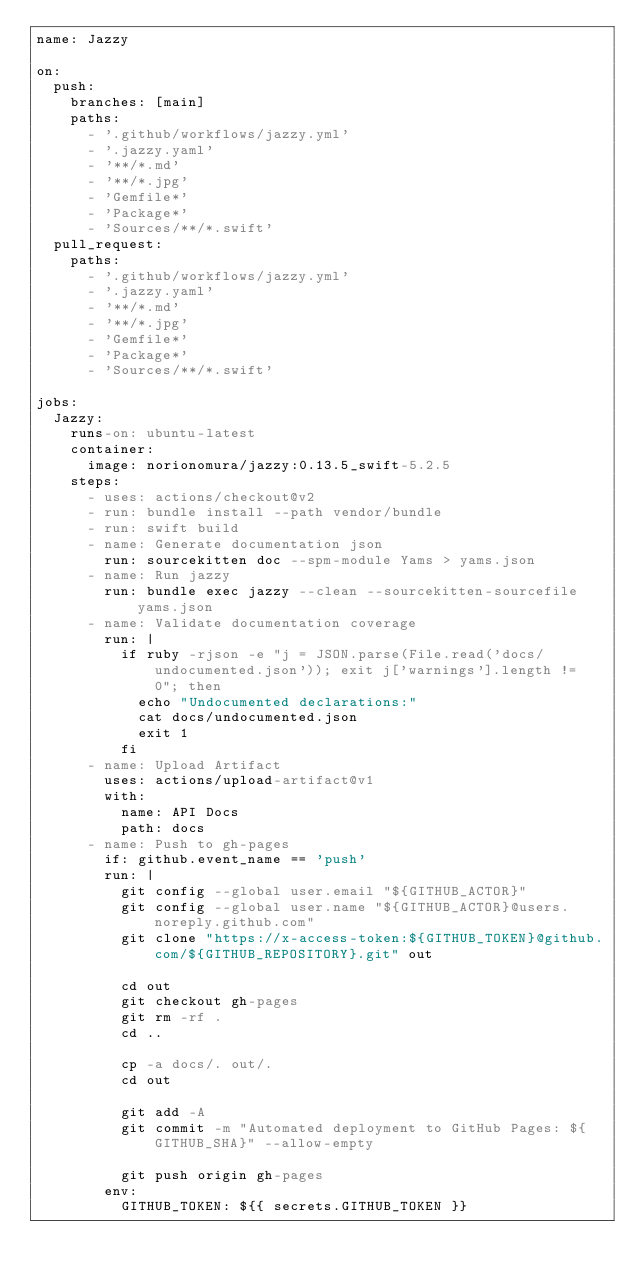<code> <loc_0><loc_0><loc_500><loc_500><_YAML_>name: Jazzy

on:
  push:
    branches: [main]
    paths: 
      - '.github/workflows/jazzy.yml'
      - '.jazzy.yaml'
      - '**/*.md'
      - '**/*.jpg'
      - 'Gemfile*'
      - 'Package*'
      - 'Sources/**/*.swift'
  pull_request:
    paths: 
      - '.github/workflows/jazzy.yml'
      - '.jazzy.yaml'
      - '**/*.md'
      - '**/*.jpg'
      - 'Gemfile*'
      - 'Package*'
      - 'Sources/**/*.swift'

jobs:
  Jazzy:
    runs-on: ubuntu-latest
    container:
      image: norionomura/jazzy:0.13.5_swift-5.2.5
    steps:
      - uses: actions/checkout@v2
      - run: bundle install --path vendor/bundle
      - run: swift build
      - name: Generate documentation json
        run: sourcekitten doc --spm-module Yams > yams.json
      - name: Run jazzy
        run: bundle exec jazzy --clean --sourcekitten-sourcefile yams.json
      - name: Validate documentation coverage
        run: |
          if ruby -rjson -e "j = JSON.parse(File.read('docs/undocumented.json')); exit j['warnings'].length != 0"; then
            echo "Undocumented declarations:"
            cat docs/undocumented.json
            exit 1
          fi
      - name: Upload Artifact
        uses: actions/upload-artifact@v1
        with:
          name: API Docs
          path: docs
      - name: Push to gh-pages
        if: github.event_name == 'push'
        run: |
          git config --global user.email "${GITHUB_ACTOR}"
          git config --global user.name "${GITHUB_ACTOR}@users.noreply.github.com"
          git clone "https://x-access-token:${GITHUB_TOKEN}@github.com/${GITHUB_REPOSITORY}.git" out

          cd out
          git checkout gh-pages
          git rm -rf .
          cd ..

          cp -a docs/. out/.
          cd out

          git add -A
          git commit -m "Automated deployment to GitHub Pages: ${GITHUB_SHA}" --allow-empty

          git push origin gh-pages
        env:
          GITHUB_TOKEN: ${{ secrets.GITHUB_TOKEN }}
</code> 